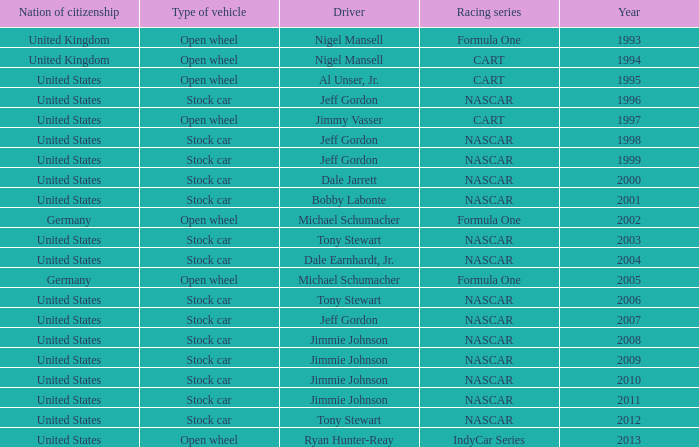What year has the vehicle of open wheel and a racing series of formula one with a Nation of citizenship in Germany. 2002, 2005. 